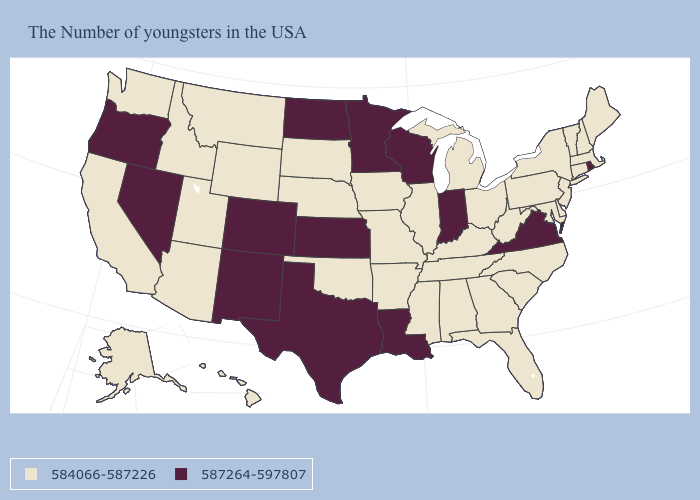What is the value of New York?
Write a very short answer. 584066-587226. Among the states that border North Carolina , which have the lowest value?
Write a very short answer. South Carolina, Georgia, Tennessee. Does the first symbol in the legend represent the smallest category?
Concise answer only. Yes. How many symbols are there in the legend?
Keep it brief. 2. Name the states that have a value in the range 587264-597807?
Short answer required. Rhode Island, Virginia, Indiana, Wisconsin, Louisiana, Minnesota, Kansas, Texas, North Dakota, Colorado, New Mexico, Nevada, Oregon. Which states have the lowest value in the USA?
Be succinct. Maine, Massachusetts, New Hampshire, Vermont, Connecticut, New York, New Jersey, Delaware, Maryland, Pennsylvania, North Carolina, South Carolina, West Virginia, Ohio, Florida, Georgia, Michigan, Kentucky, Alabama, Tennessee, Illinois, Mississippi, Missouri, Arkansas, Iowa, Nebraska, Oklahoma, South Dakota, Wyoming, Utah, Montana, Arizona, Idaho, California, Washington, Alaska, Hawaii. Among the states that border Washington , does Oregon have the highest value?
Give a very brief answer. Yes. Name the states that have a value in the range 587264-597807?
Keep it brief. Rhode Island, Virginia, Indiana, Wisconsin, Louisiana, Minnesota, Kansas, Texas, North Dakota, Colorado, New Mexico, Nevada, Oregon. Which states have the lowest value in the Northeast?
Write a very short answer. Maine, Massachusetts, New Hampshire, Vermont, Connecticut, New York, New Jersey, Pennsylvania. Does Alabama have the lowest value in the USA?
Be succinct. Yes. Which states hav the highest value in the MidWest?
Quick response, please. Indiana, Wisconsin, Minnesota, Kansas, North Dakota. What is the value of Montana?
Be succinct. 584066-587226. What is the highest value in the USA?
Short answer required. 587264-597807. Among the states that border New Hampshire , which have the lowest value?
Answer briefly. Maine, Massachusetts, Vermont. Name the states that have a value in the range 587264-597807?
Keep it brief. Rhode Island, Virginia, Indiana, Wisconsin, Louisiana, Minnesota, Kansas, Texas, North Dakota, Colorado, New Mexico, Nevada, Oregon. 